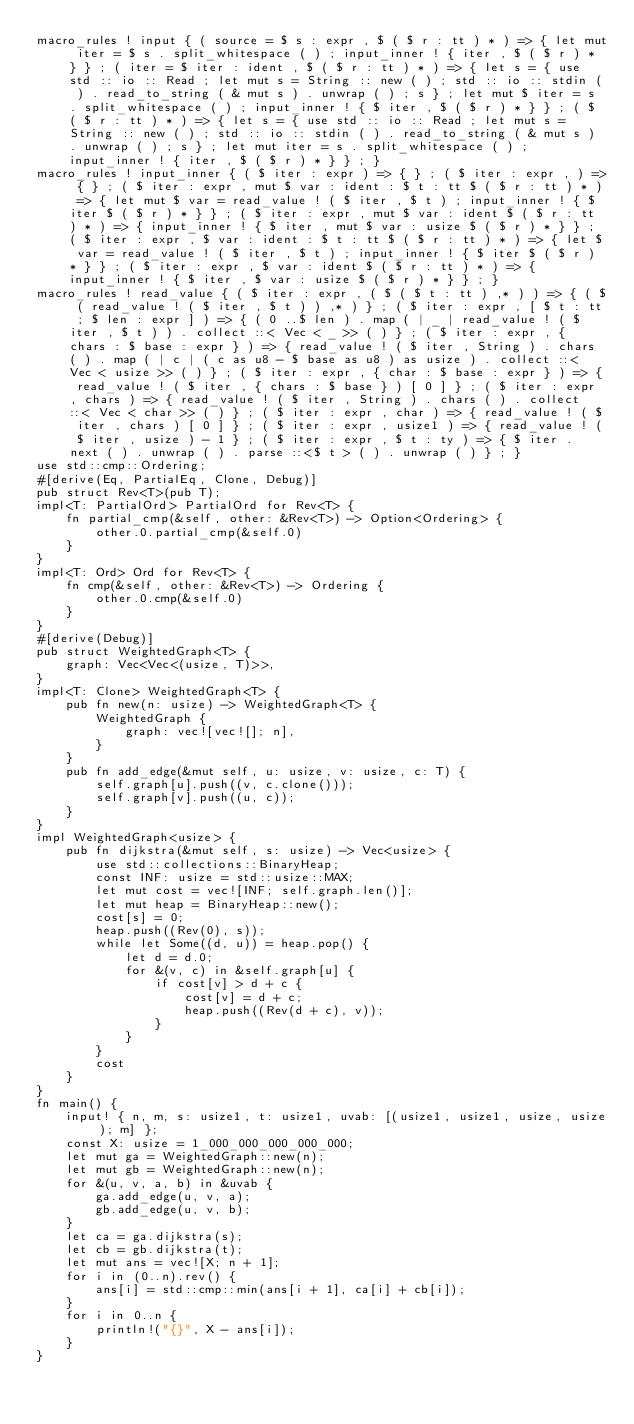Convert code to text. <code><loc_0><loc_0><loc_500><loc_500><_Rust_>macro_rules ! input { ( source = $ s : expr , $ ( $ r : tt ) * ) => { let mut iter = $ s . split_whitespace ( ) ; input_inner ! { iter , $ ( $ r ) * } } ; ( iter = $ iter : ident , $ ( $ r : tt ) * ) => { let s = { use std :: io :: Read ; let mut s = String :: new ( ) ; std :: io :: stdin ( ) . read_to_string ( & mut s ) . unwrap ( ) ; s } ; let mut $ iter = s . split_whitespace ( ) ; input_inner ! { $ iter , $ ( $ r ) * } } ; ( $ ( $ r : tt ) * ) => { let s = { use std :: io :: Read ; let mut s = String :: new ( ) ; std :: io :: stdin ( ) . read_to_string ( & mut s ) . unwrap ( ) ; s } ; let mut iter = s . split_whitespace ( ) ; input_inner ! { iter , $ ( $ r ) * } } ; }
macro_rules ! input_inner { ( $ iter : expr ) => { } ; ( $ iter : expr , ) => { } ; ( $ iter : expr , mut $ var : ident : $ t : tt $ ( $ r : tt ) * ) => { let mut $ var = read_value ! ( $ iter , $ t ) ; input_inner ! { $ iter $ ( $ r ) * } } ; ( $ iter : expr , mut $ var : ident $ ( $ r : tt ) * ) => { input_inner ! { $ iter , mut $ var : usize $ ( $ r ) * } } ; ( $ iter : expr , $ var : ident : $ t : tt $ ( $ r : tt ) * ) => { let $ var = read_value ! ( $ iter , $ t ) ; input_inner ! { $ iter $ ( $ r ) * } } ; ( $ iter : expr , $ var : ident $ ( $ r : tt ) * ) => { input_inner ! { $ iter , $ var : usize $ ( $ r ) * } } ; }
macro_rules ! read_value { ( $ iter : expr , ( $ ( $ t : tt ) ,* ) ) => { ( $ ( read_value ! ( $ iter , $ t ) ) ,* ) } ; ( $ iter : expr , [ $ t : tt ; $ len : expr ] ) => { ( 0 ..$ len ) . map ( | _ | read_value ! ( $ iter , $ t ) ) . collect ::< Vec < _ >> ( ) } ; ( $ iter : expr , { chars : $ base : expr } ) => { read_value ! ( $ iter , String ) . chars ( ) . map ( | c | ( c as u8 - $ base as u8 ) as usize ) . collect ::< Vec < usize >> ( ) } ; ( $ iter : expr , { char : $ base : expr } ) => { read_value ! ( $ iter , { chars : $ base } ) [ 0 ] } ; ( $ iter : expr , chars ) => { read_value ! ( $ iter , String ) . chars ( ) . collect ::< Vec < char >> ( ) } ; ( $ iter : expr , char ) => { read_value ! ( $ iter , chars ) [ 0 ] } ; ( $ iter : expr , usize1 ) => { read_value ! ( $ iter , usize ) - 1 } ; ( $ iter : expr , $ t : ty ) => { $ iter . next ( ) . unwrap ( ) . parse ::<$ t > ( ) . unwrap ( ) } ; }
use std::cmp::Ordering;
#[derive(Eq, PartialEq, Clone, Debug)]
pub struct Rev<T>(pub T);
impl<T: PartialOrd> PartialOrd for Rev<T> {
    fn partial_cmp(&self, other: &Rev<T>) -> Option<Ordering> {
        other.0.partial_cmp(&self.0)
    }
}
impl<T: Ord> Ord for Rev<T> {
    fn cmp(&self, other: &Rev<T>) -> Ordering {
        other.0.cmp(&self.0)
    }
}
#[derive(Debug)]
pub struct WeightedGraph<T> {
    graph: Vec<Vec<(usize, T)>>,
}
impl<T: Clone> WeightedGraph<T> {
    pub fn new(n: usize) -> WeightedGraph<T> {
        WeightedGraph {
            graph: vec![vec![]; n],
        }
    }
    pub fn add_edge(&mut self, u: usize, v: usize, c: T) {
        self.graph[u].push((v, c.clone()));
        self.graph[v].push((u, c));
    }
}
impl WeightedGraph<usize> {
    pub fn dijkstra(&mut self, s: usize) -> Vec<usize> {
        use std::collections::BinaryHeap;
        const INF: usize = std::usize::MAX;
        let mut cost = vec![INF; self.graph.len()];
        let mut heap = BinaryHeap::new();
        cost[s] = 0;
        heap.push((Rev(0), s));
        while let Some((d, u)) = heap.pop() {
            let d = d.0;
            for &(v, c) in &self.graph[u] {
                if cost[v] > d + c {
                    cost[v] = d + c;
                    heap.push((Rev(d + c), v));
                }
            }
        }
        cost
    }
}
fn main() {
    input! { n, m, s: usize1, t: usize1, uvab: [(usize1, usize1, usize, usize); m] };
    const X: usize = 1_000_000_000_000_000;
    let mut ga = WeightedGraph::new(n);
    let mut gb = WeightedGraph::new(n);
    for &(u, v, a, b) in &uvab {
        ga.add_edge(u, v, a);
        gb.add_edge(u, v, b);
    }
    let ca = ga.dijkstra(s);
    let cb = gb.dijkstra(t);
    let mut ans = vec![X; n + 1];
    for i in (0..n).rev() {
        ans[i] = std::cmp::min(ans[i + 1], ca[i] + cb[i]);
    }
    for i in 0..n {
        println!("{}", X - ans[i]);
    }
}
</code> 